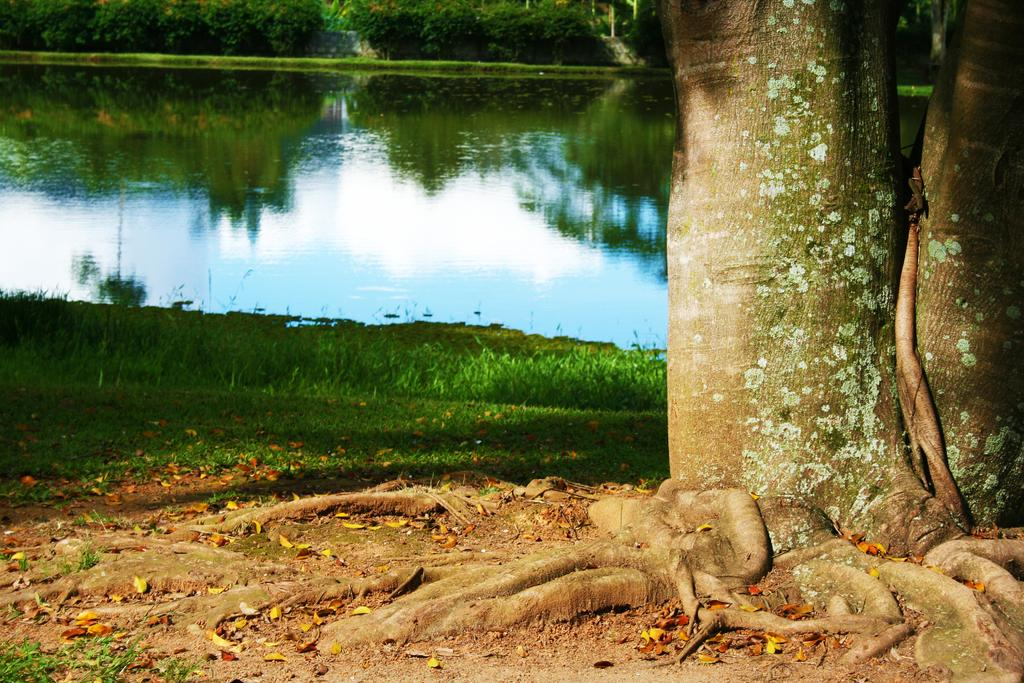What can be seen on the right side of the image? There is a tree trunk on the right side of the image. What is visible in the background of the image? There is a lake and trees in the background of the image. What type of vegetation is near the lake? There is green grass visible near the lake. How many cows are wearing collars in the image? There are no cows or collars present in the image. What is the temperature like in the image? The temperature or heat level cannot be determined from the image, as it only shows a tree trunk, a lake, trees, and green grass near the lake. 